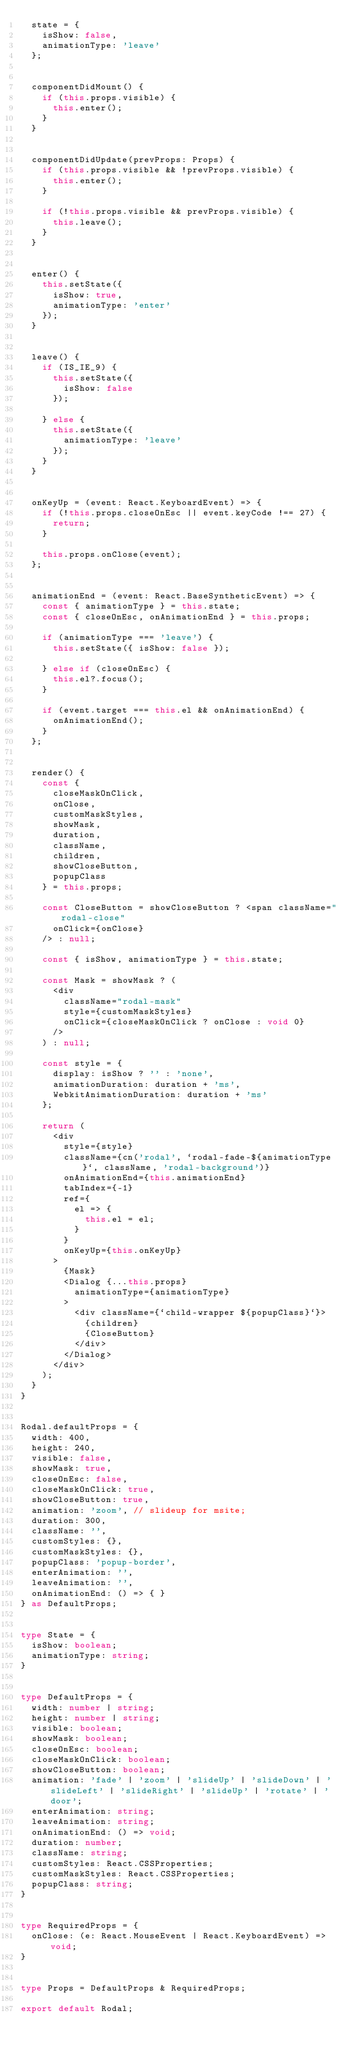<code> <loc_0><loc_0><loc_500><loc_500><_TypeScript_>  state = {
    isShow: false,
    animationType: 'leave'
  };


  componentDidMount() {
    if (this.props.visible) {
      this.enter();
    }
  }


  componentDidUpdate(prevProps: Props) {
    if (this.props.visible && !prevProps.visible) {
      this.enter();
    }

    if (!this.props.visible && prevProps.visible) {
      this.leave();
    }
  }


  enter() {
    this.setState({
      isShow: true,
      animationType: 'enter'
    });
  }


  leave() {
    if (IS_IE_9) {
      this.setState({
        isShow: false
      });

    } else {
      this.setState({
        animationType: 'leave'
      });
    }
  }


  onKeyUp = (event: React.KeyboardEvent) => {
    if (!this.props.closeOnEsc || event.keyCode !== 27) {
      return;
    }

    this.props.onClose(event);
  };


  animationEnd = (event: React.BaseSyntheticEvent) => {
    const { animationType } = this.state;
    const { closeOnEsc, onAnimationEnd } = this.props;

    if (animationType === 'leave') {
      this.setState({ isShow: false });

    } else if (closeOnEsc) {
      this.el?.focus();
    }

    if (event.target === this.el && onAnimationEnd) {
      onAnimationEnd();
    }
  };


  render() {
    const {
      closeMaskOnClick,
      onClose,
      customMaskStyles,
      showMask,
      duration,
      className,
      children,
      showCloseButton,
      popupClass
    } = this.props;

    const CloseButton = showCloseButton ? <span className="rodal-close"
      onClick={onClose}
    /> : null;

    const { isShow, animationType } = this.state;

    const Mask = showMask ? (
      <div
        className="rodal-mask"
        style={customMaskStyles}
        onClick={closeMaskOnClick ? onClose : void 0}
      />
    ) : null;

    const style = {
      display: isShow ? '' : 'none',
      animationDuration: duration + 'ms',
      WebkitAnimationDuration: duration + 'ms'
    };

    return (
      <div
        style={style}
        className={cn('rodal', `rodal-fade-${animationType}`, className, 'rodal-background')}
        onAnimationEnd={this.animationEnd}
        tabIndex={-1}
        ref={
          el => {
            this.el = el;
          }
        }
        onKeyUp={this.onKeyUp}
      >
        {Mask}
        <Dialog {...this.props}
          animationType={animationType}
        >
          <div className={`child-wrapper ${popupClass}`}>
            {children}
            {CloseButton}
          </div>
        </Dialog>
      </div>
    );
  }
}


Rodal.defaultProps = {
  width: 400,
  height: 240,
  visible: false,
  showMask: true,
  closeOnEsc: false,
  closeMaskOnClick: true,
  showCloseButton: true,
  animation: 'zoom', // slideup for msite;
  duration: 300,
  className: '',
  customStyles: {},
  customMaskStyles: {},
  popupClass: 'popup-border',
  enterAnimation: '',
  leaveAnimation: '',
  onAnimationEnd: () => { }
} as DefaultProps;


type State = {
  isShow: boolean;
  animationType: string;
}


type DefaultProps = {
  width: number | string;
  height: number | string;
  visible: boolean;
  showMask: boolean;
  closeOnEsc: boolean;
  closeMaskOnClick: boolean;
  showCloseButton: boolean;
  animation: 'fade' | 'zoom' | 'slideUp' | 'slideDown' | 'slideLeft' | 'slideRight' | 'slideUp' | 'rotate' | 'door';
  enterAnimation: string;
  leaveAnimation: string;
  onAnimationEnd: () => void;
  duration: number;
  className: string;
  customStyles: React.CSSProperties;
  customMaskStyles: React.CSSProperties;
  popupClass: string;
}


type RequiredProps = {
  onClose: (e: React.MouseEvent | React.KeyboardEvent) => void;
}


type Props = DefaultProps & RequiredProps;

export default Rodal;
</code> 